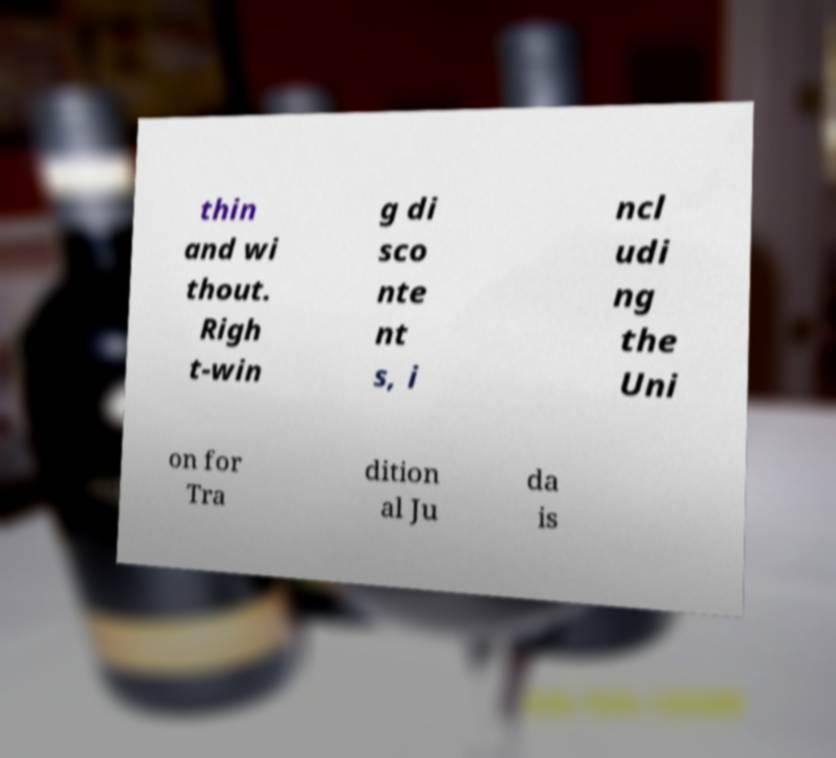Can you read and provide the text displayed in the image?This photo seems to have some interesting text. Can you extract and type it out for me? thin and wi thout. Righ t-win g di sco nte nt s, i ncl udi ng the Uni on for Tra dition al Ju da is 